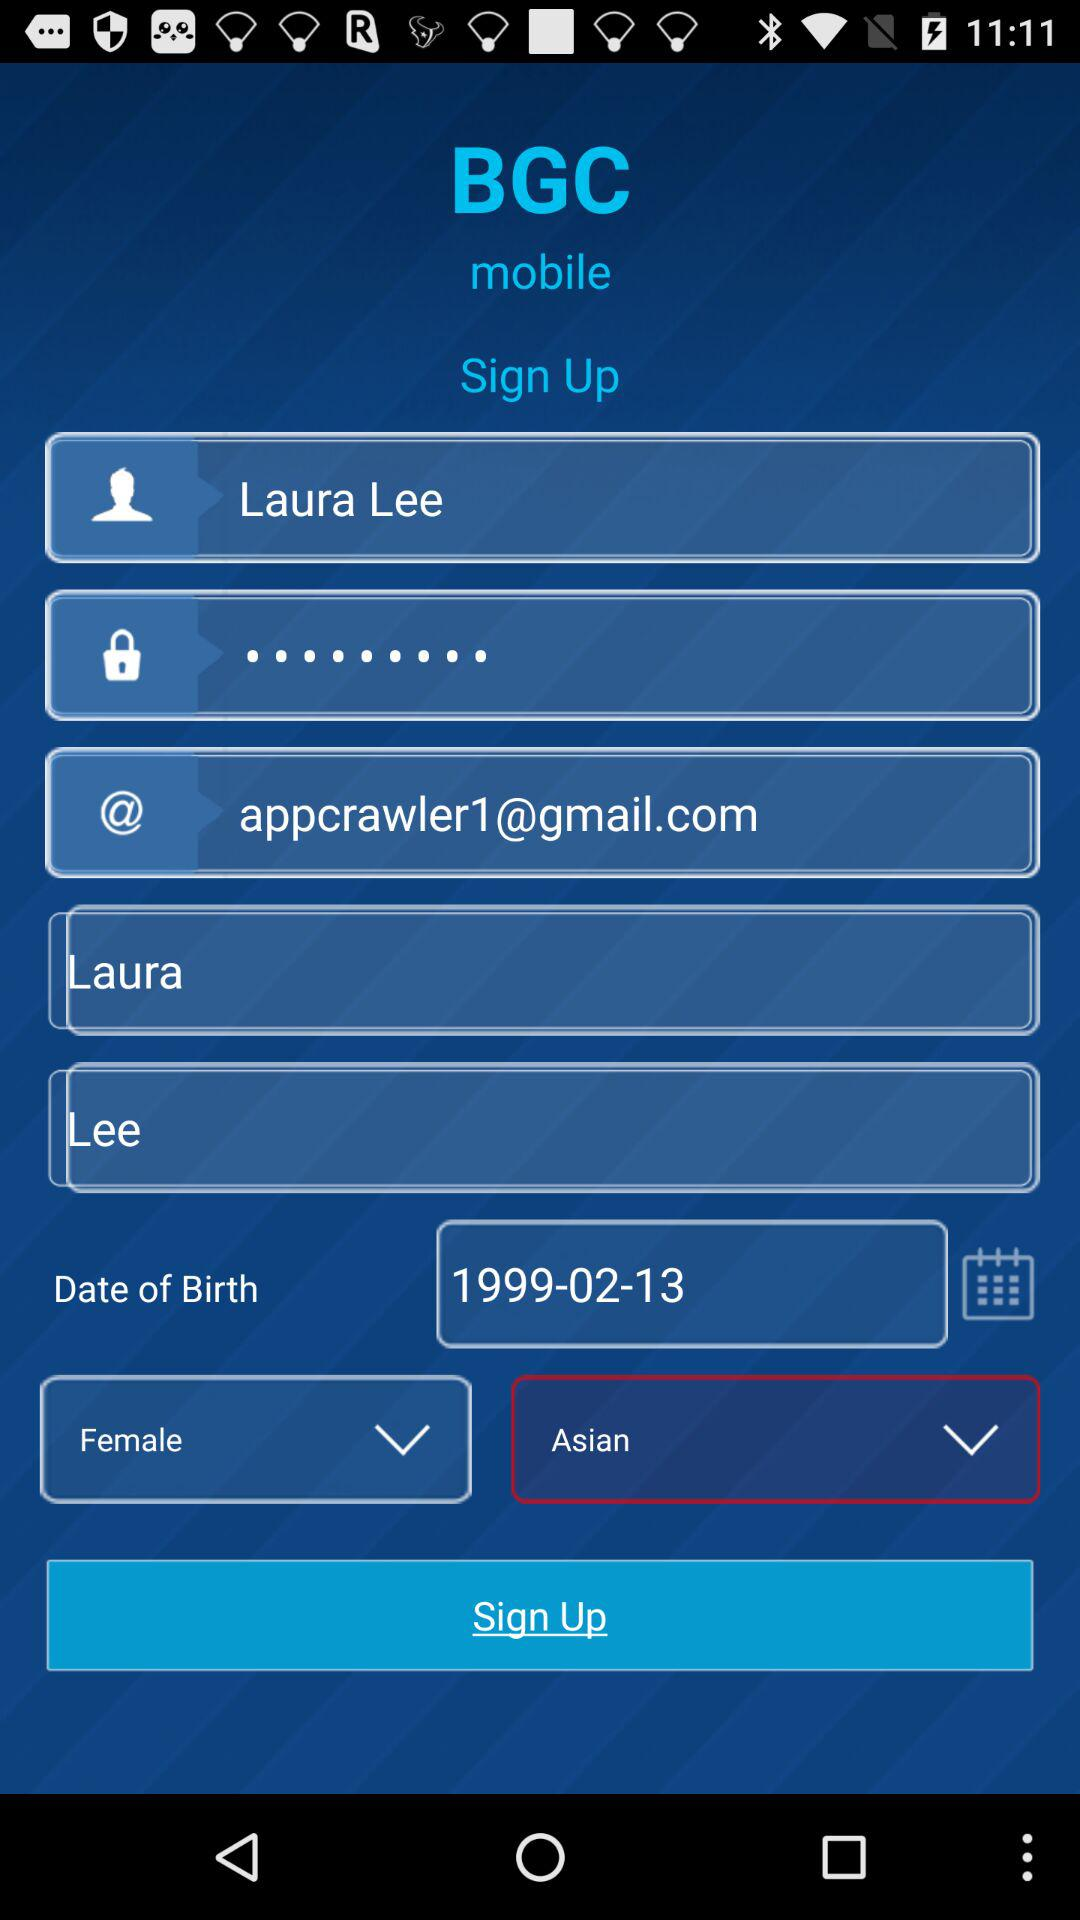What is the origin given? The given origin is Asian. 